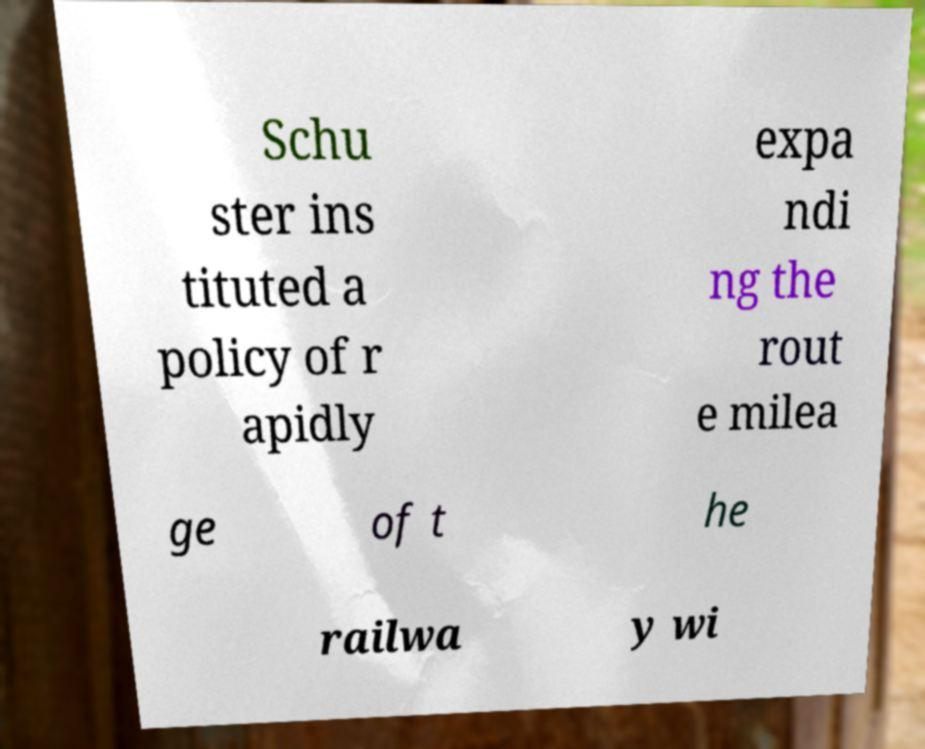Can you read and provide the text displayed in the image?This photo seems to have some interesting text. Can you extract and type it out for me? Schu ster ins tituted a policy of r apidly expa ndi ng the rout e milea ge of t he railwa y wi 